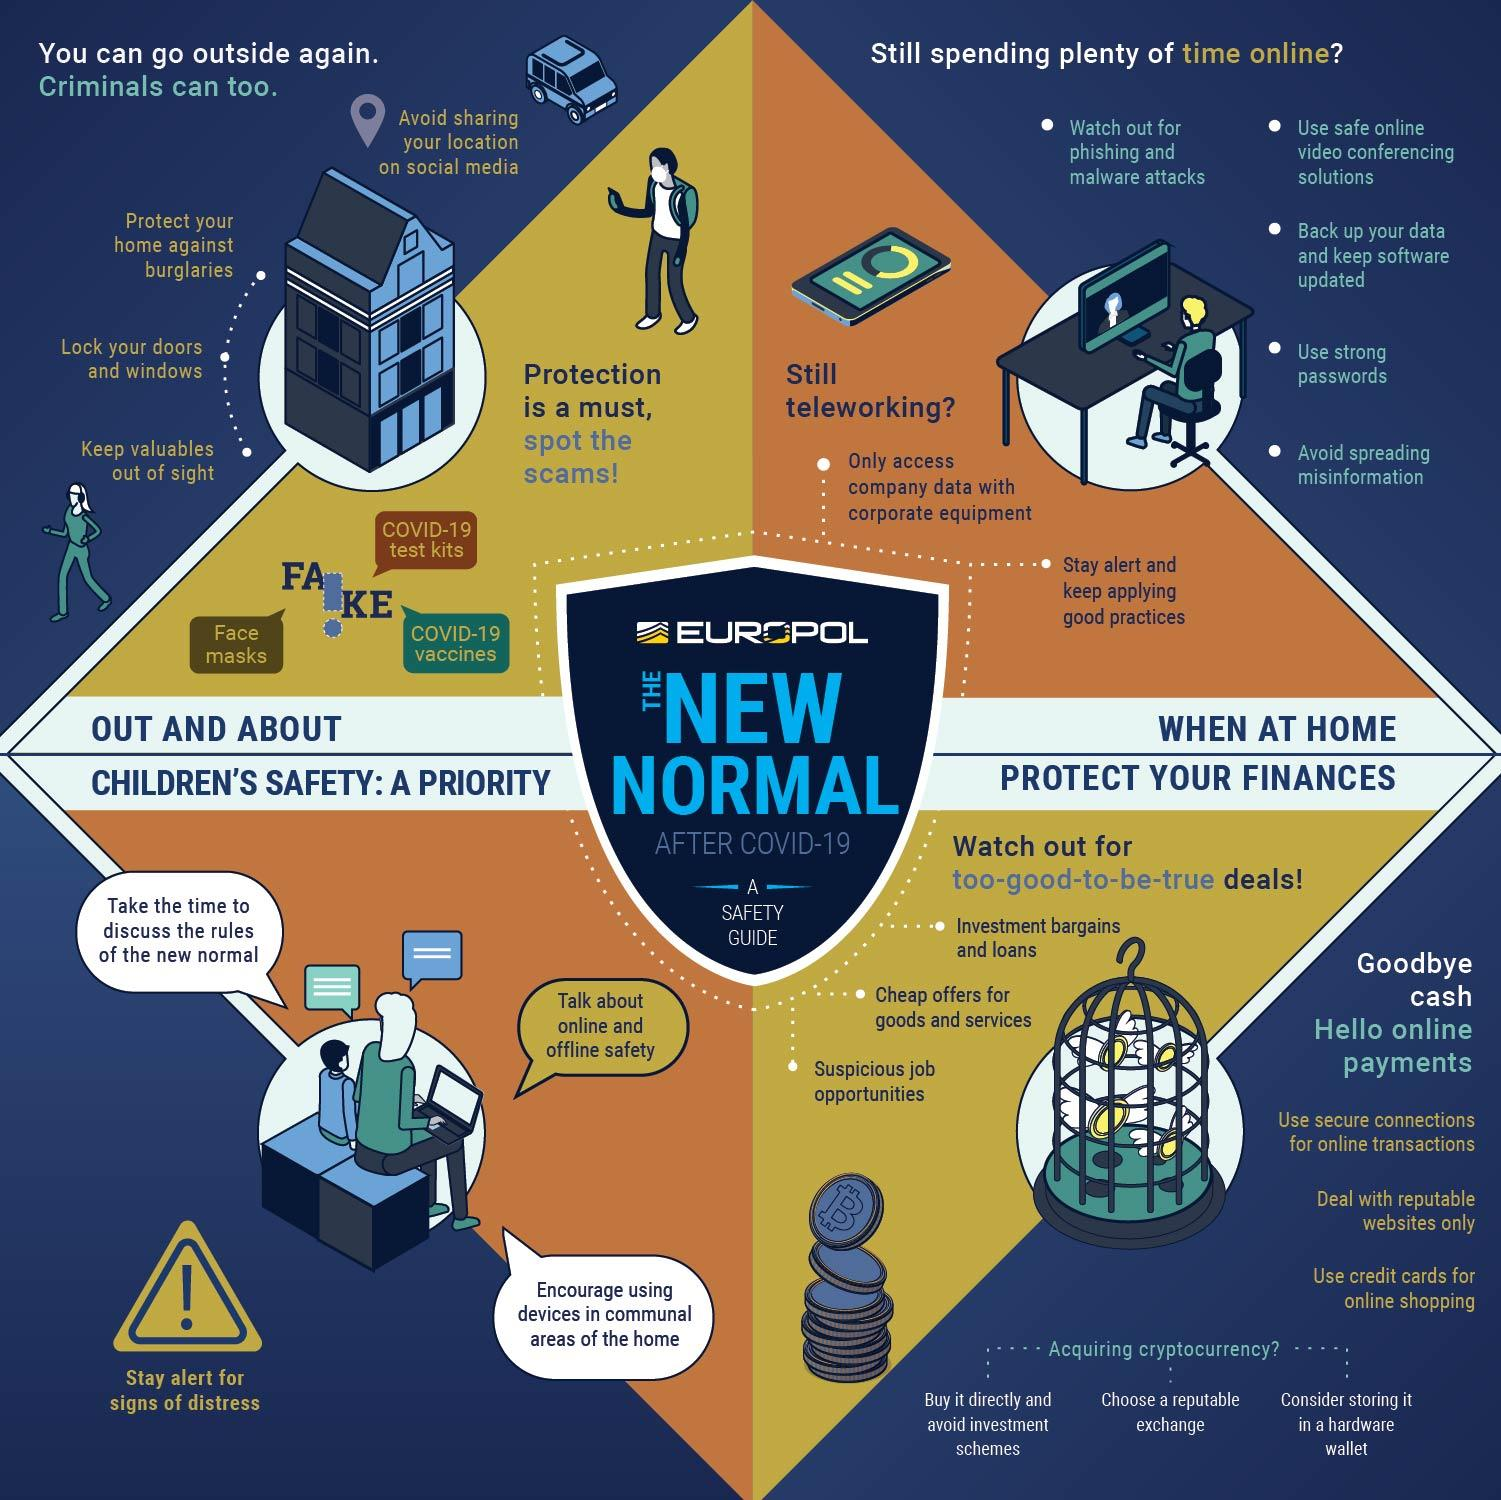List a handful of essential elements in this visual. It is important to ensure that only authorized individuals access company data when working with office gadgets by using corporate equipment and adhering to strict security protocols. When engaging in online activities, it is important to select high-quality, trustworthy websites that are known for their credibility and reliability. During and after a pandemic, online payments are the best kind of money transactions. It is essential to use strong passwords while engaging in online activities in order to ensure the security of personal information and prevent unauthorized access. The infographic, which is fake, lists 3 gears as effective against corona. 